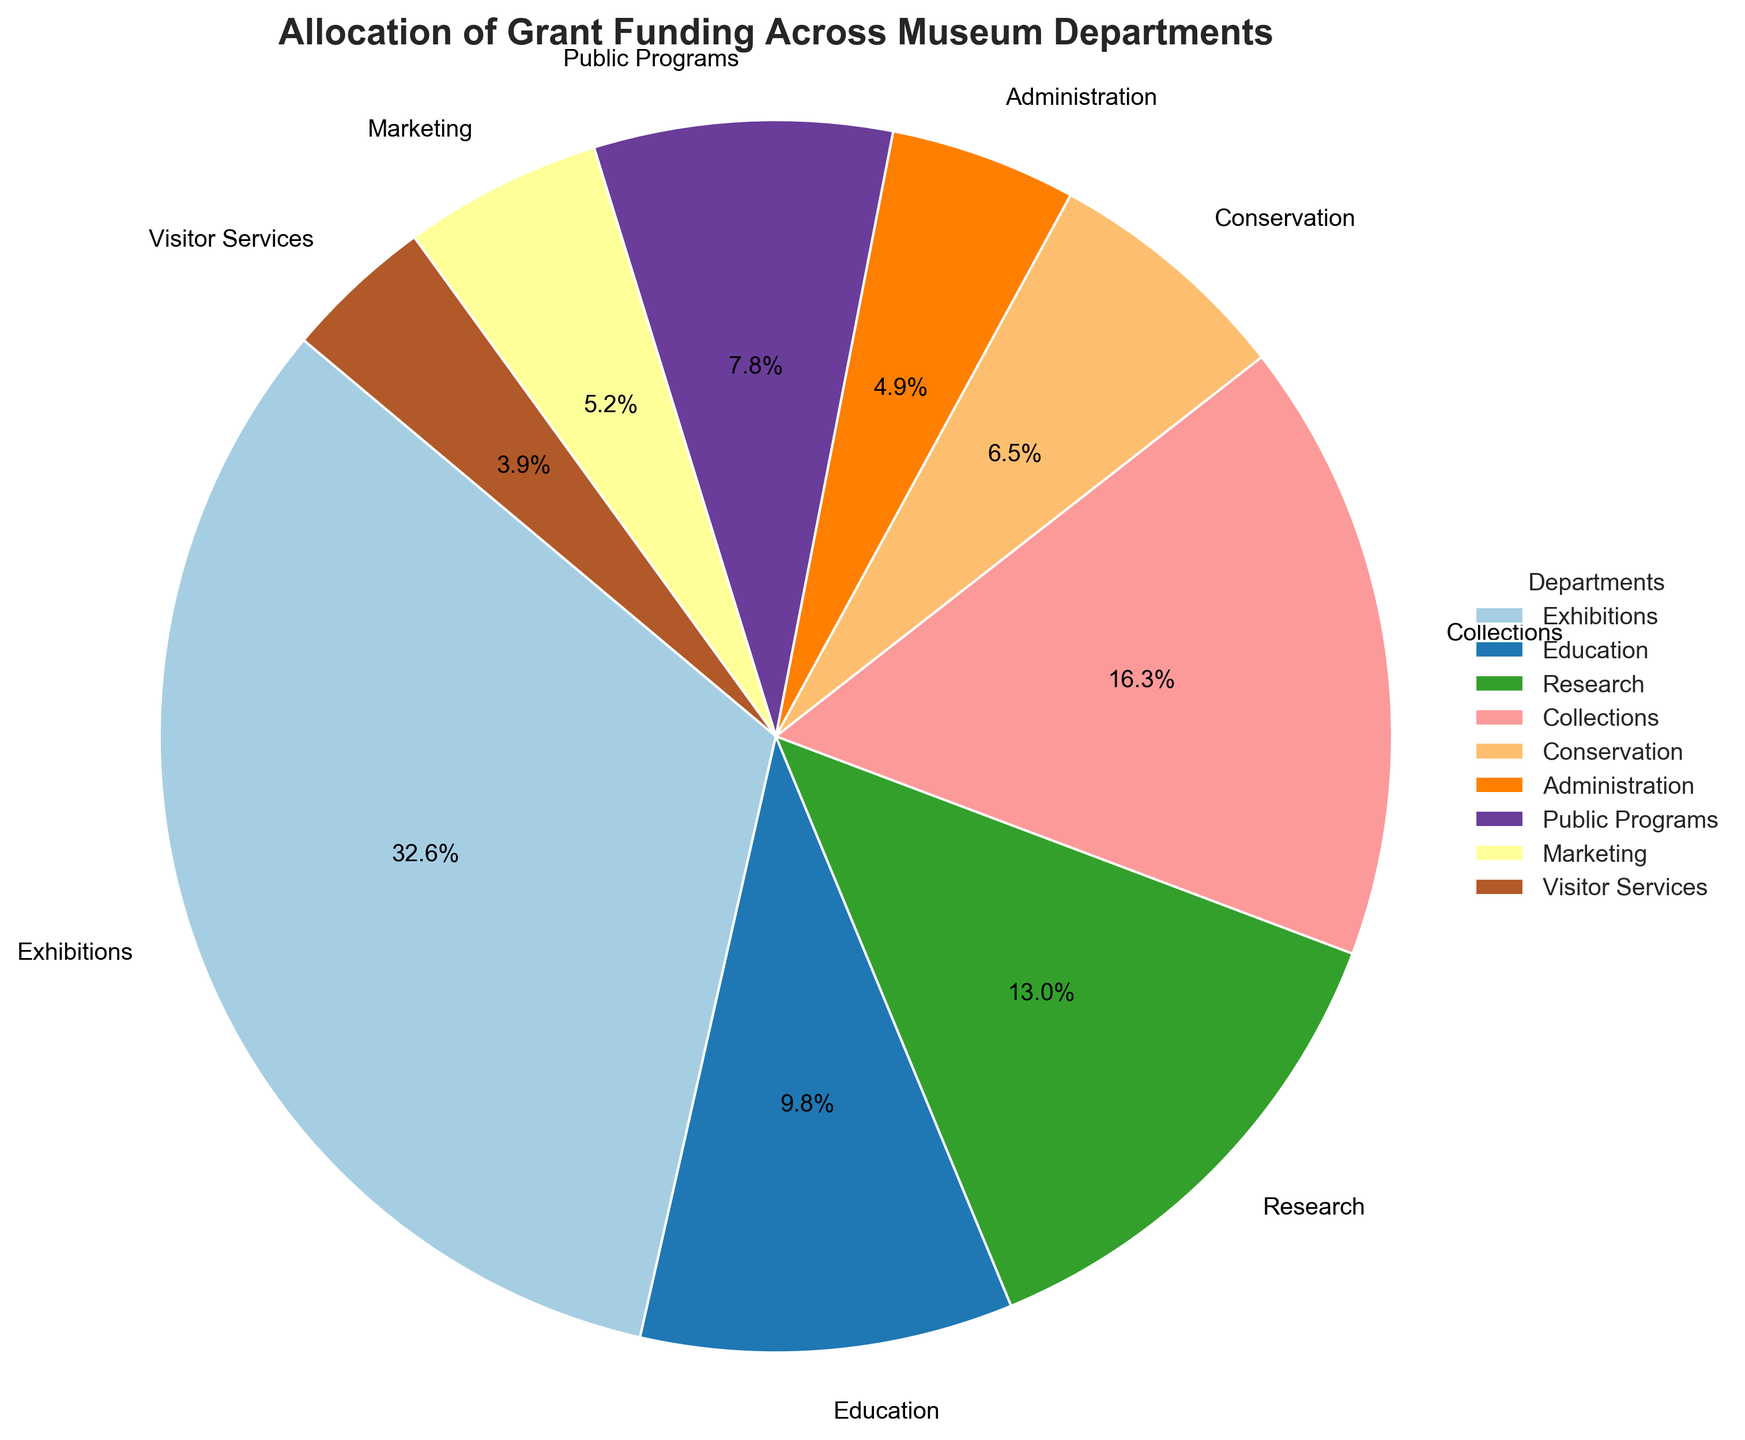What percentage of the total funding does the Collections department receive? The pie chart shows the percentage of total funding allocated to each department. Locate the Collections department in the chart and read off its percentage.
Answer: 16.7% Which department receives the largest portion of the grant funding? Examine the pie chart and identify which department slice is the largest. The Exhibitions department has the largest slice.
Answer: Exhibitions Is the funding amount for Visitor Services greater or less than the amount for Conservation? Look at the slices for Visitor Services and Conservation. The slice for Visitor Services is smaller than that for Conservation.
Answer: Less What is the combined funding percentage allocated to Research and Education? Find the slices for Research and Education. Add their percentages together: Research (26.7%) + Education (20%) = 46.7%.
Answer: 46.7% Are the funding amounts for Public Programs and Marketing more or less similar? Observe the sizes of the slices for Public Programs and Marketing. They are quite close in size.
Answer: Similar What is the total funding percentage for departments with less than $10,000 in funding? Identify the departments with less than $10,000: Conservation (10%) and Visitor Services (6.7%). Add their percentages: 10% + 6.7% = 16.7%.
Answer: 16.7% What is the difference in funding percentage between Administration and Marketing? Locate the slices for Administration (10%) and Marketing (20%) and subtract their percentages: 20% - 10% = 10%.
Answer: 10% Which departments receive less funding than Public Programs? Compare the slices visually or by percentage to the slice for Public Programs. Departments with less funding are Marketing and Visitor Services.
Answer: Marketing, Visitor Services What is the average funding percentage for Exhibitions, Research, and Collections? For these departments: Exhibitions (33.3%), Research (20%), and Collections (16.7%). Add their percentages and divide by 3: (33.3% + 20% + 16.7%) / 3 = 23.3%.
Answer: 23.3% 